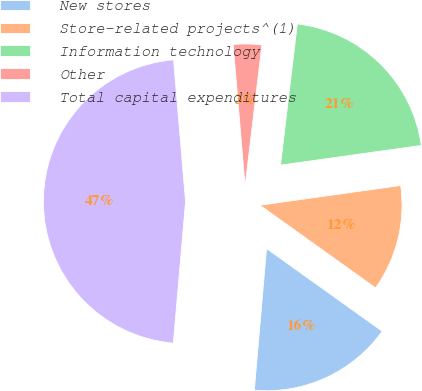Convert chart to OTSL. <chart><loc_0><loc_0><loc_500><loc_500><pie_chart><fcel>New stores<fcel>Store-related projects^(1)<fcel>Information technology<fcel>Other<fcel>Total capital expenditures<nl><fcel>16.49%<fcel>12.09%<fcel>20.9%<fcel>3.23%<fcel>47.29%<nl></chart> 